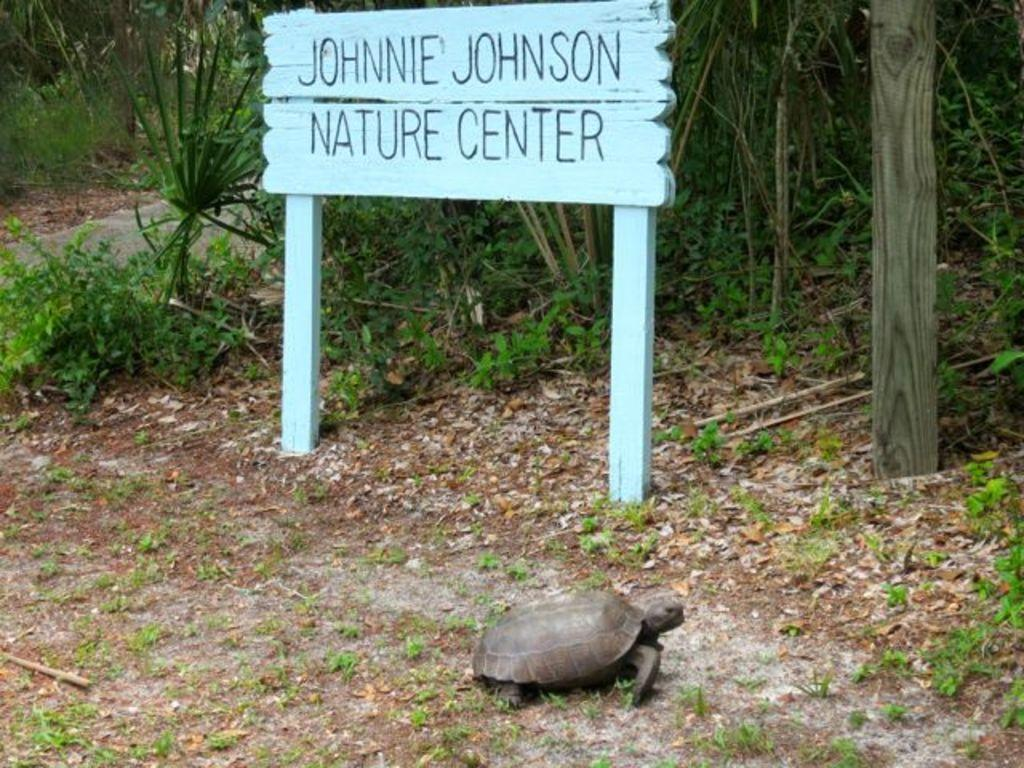What animal can be seen on the ground in the image? There is a turtle on the ground in the image. What type of environment is visible in the background of the image? There are trees in the background of the image. What other objects can be seen in the background of the image? There is a name board and a pole in the background of the image. What type of vegetable is being used as a ticket in the image? There is no vegetable or ticket present in the image. 